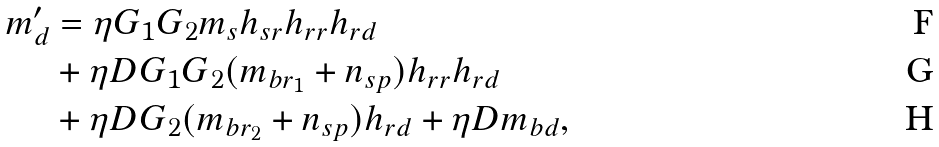Convert formula to latex. <formula><loc_0><loc_0><loc_500><loc_500>m ^ { \prime } _ { d } & = \eta G _ { 1 } G _ { 2 } m _ { s } h _ { s r } h _ { r r } h _ { r d } \\ & + \eta D G _ { 1 } G _ { 2 } ( m _ { b r _ { 1 } } + n _ { s p } ) h _ { r r } h _ { r d } \\ & + \eta D G _ { 2 } ( m _ { b r _ { 2 } } + n _ { s p } ) h _ { r d } + \eta D m _ { b d } ,</formula> 